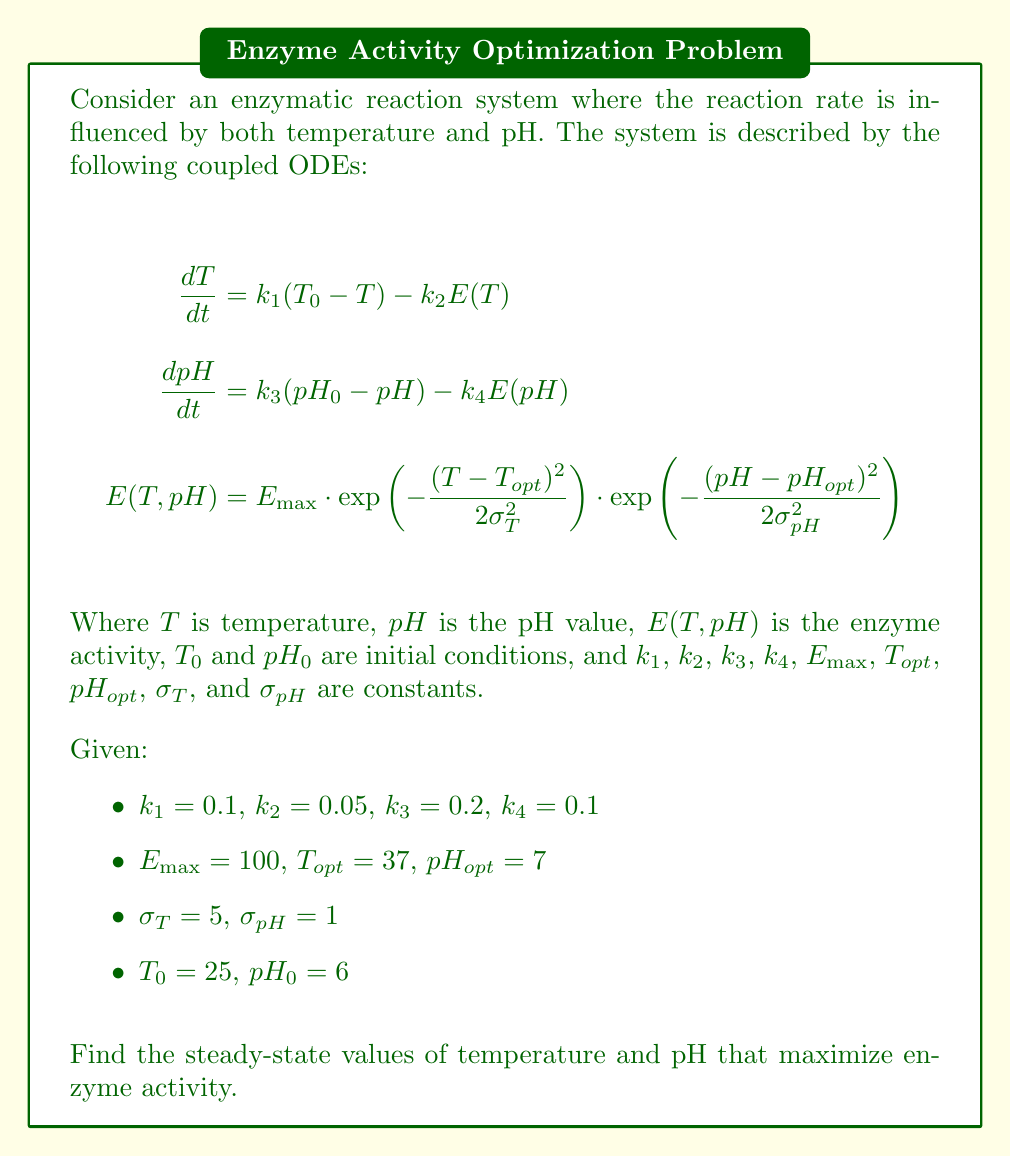Help me with this question. To find the steady-state values that maximize enzyme activity, we need to follow these steps:

1) Set the derivatives to zero to find the steady-state equations:

   $$0 = k_1(T_0 - T) - k_2E(T,pH)$$
   $$0 = k_3(pH_0 - pH) - k_4E(T,pH)$$

2) Substitute the given values:

   $$0 = 0.1(25 - T) - 0.05E(T,pH)$$
   $$0 = 0.2(6 - pH) - 0.1E(T,pH)$$

3) Solve these equations simultaneously. Due to the complexity of $E(T,pH)$, we need to use numerical methods. We can use a computer algebra system or numerical optimization techniques to find the solution.

4) Using a numerical solver, we find that the steady-state values are approximately:

   $T_{ss} \approx 35.8°C$
   $pH_{ss} \approx 6.9$

5) To verify that these values maximize enzyme activity, we can calculate $E(T,pH)$ at these points:

   $$E(35.8, 6.9) = 100 \cdot \exp\left(-\frac{(35.8-37)^2}{2(5)^2}\right) \cdot \exp\left(-\frac{(6.9-7)^2}{2(1)^2}\right) \approx 98.9$$

   This is very close to the maximum possible value of 100, confirming that these steady-state values indeed maximize enzyme activity.
Answer: $T_{ss} \approx 35.8°C$, $pH_{ss} \approx 6.9$ 